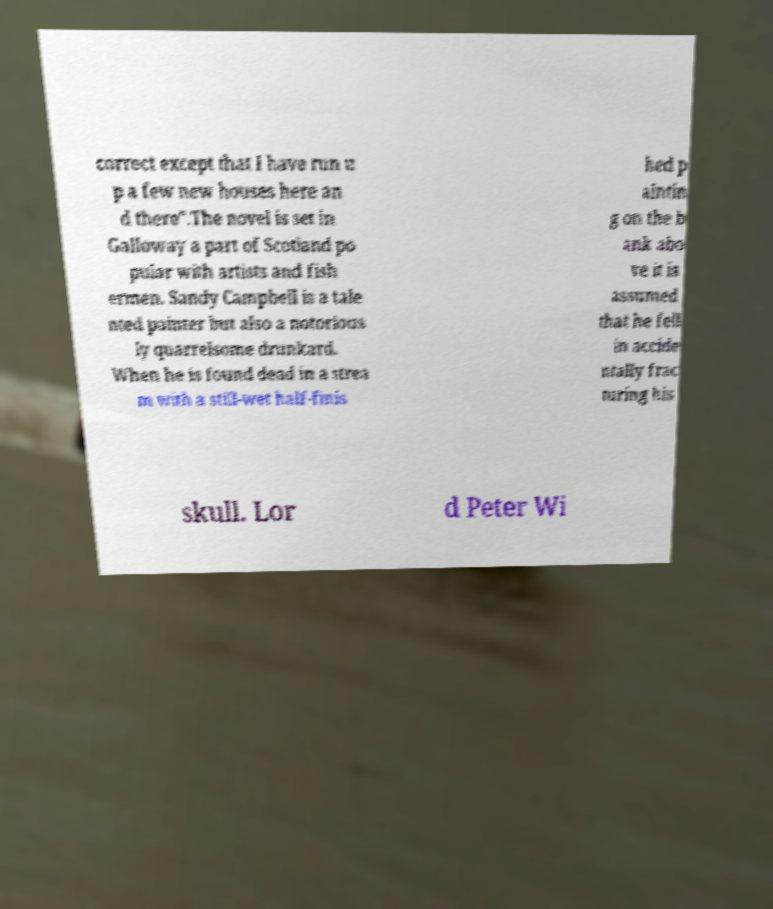What messages or text are displayed in this image? I need them in a readable, typed format. correct except that I have run u p a few new houses here an d there".The novel is set in Galloway a part of Scotland po pular with artists and fish ermen. Sandy Campbell is a tale nted painter but also a notorious ly quarrelsome drunkard. When he is found dead in a strea m with a still-wet half-finis hed p aintin g on the b ank abo ve it is assumed that he fell in accide ntally frac turing his skull. Lor d Peter Wi 